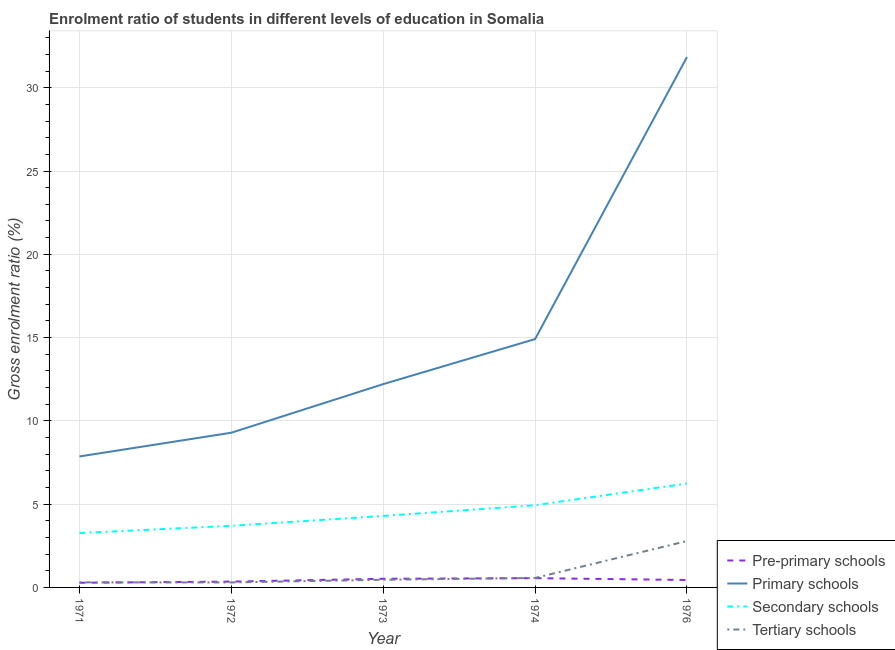How many different coloured lines are there?
Provide a short and direct response. 4. What is the gross enrolment ratio in pre-primary schools in 1974?
Ensure brevity in your answer.  0.56. Across all years, what is the maximum gross enrolment ratio in primary schools?
Offer a terse response. 31.84. Across all years, what is the minimum gross enrolment ratio in secondary schools?
Your answer should be very brief. 3.26. In which year was the gross enrolment ratio in pre-primary schools maximum?
Provide a succinct answer. 1974. What is the total gross enrolment ratio in pre-primary schools in the graph?
Provide a short and direct response. 2.15. What is the difference between the gross enrolment ratio in primary schools in 1974 and that in 1976?
Give a very brief answer. -16.93. What is the difference between the gross enrolment ratio in primary schools in 1973 and the gross enrolment ratio in secondary schools in 1976?
Keep it short and to the point. 5.97. What is the average gross enrolment ratio in secondary schools per year?
Your answer should be very brief. 4.49. In the year 1973, what is the difference between the gross enrolment ratio in primary schools and gross enrolment ratio in secondary schools?
Your answer should be compact. 7.91. What is the ratio of the gross enrolment ratio in pre-primary schools in 1971 to that in 1973?
Your answer should be very brief. 0.54. Is the gross enrolment ratio in pre-primary schools in 1971 less than that in 1976?
Your response must be concise. Yes. What is the difference between the highest and the second highest gross enrolment ratio in secondary schools?
Offer a very short reply. 1.3. What is the difference between the highest and the lowest gross enrolment ratio in primary schools?
Your answer should be compact. 23.98. Is the sum of the gross enrolment ratio in secondary schools in 1972 and 1973 greater than the maximum gross enrolment ratio in primary schools across all years?
Provide a succinct answer. No. Is it the case that in every year, the sum of the gross enrolment ratio in secondary schools and gross enrolment ratio in pre-primary schools is greater than the sum of gross enrolment ratio in tertiary schools and gross enrolment ratio in primary schools?
Your answer should be compact. Yes. Does the gross enrolment ratio in secondary schools monotonically increase over the years?
Make the answer very short. Yes. Is the gross enrolment ratio in tertiary schools strictly greater than the gross enrolment ratio in secondary schools over the years?
Keep it short and to the point. No. Is the gross enrolment ratio in pre-primary schools strictly less than the gross enrolment ratio in tertiary schools over the years?
Provide a short and direct response. No. How many years are there in the graph?
Give a very brief answer. 5. What is the difference between two consecutive major ticks on the Y-axis?
Make the answer very short. 5. Does the graph contain grids?
Provide a succinct answer. Yes. Where does the legend appear in the graph?
Offer a terse response. Bottom right. How are the legend labels stacked?
Ensure brevity in your answer.  Vertical. What is the title of the graph?
Your answer should be compact. Enrolment ratio of students in different levels of education in Somalia. What is the label or title of the Y-axis?
Provide a succinct answer. Gross enrolment ratio (%). What is the Gross enrolment ratio (%) in Pre-primary schools in 1971?
Give a very brief answer. 0.28. What is the Gross enrolment ratio (%) in Primary schools in 1971?
Your answer should be compact. 7.86. What is the Gross enrolment ratio (%) in Secondary schools in 1971?
Your response must be concise. 3.26. What is the Gross enrolment ratio (%) in Tertiary schools in 1971?
Your response must be concise. 0.3. What is the Gross enrolment ratio (%) in Pre-primary schools in 1972?
Offer a terse response. 0.35. What is the Gross enrolment ratio (%) in Primary schools in 1972?
Your response must be concise. 9.29. What is the Gross enrolment ratio (%) in Secondary schools in 1972?
Ensure brevity in your answer.  3.7. What is the Gross enrolment ratio (%) of Tertiary schools in 1972?
Your answer should be compact. 0.3. What is the Gross enrolment ratio (%) of Pre-primary schools in 1973?
Offer a very short reply. 0.52. What is the Gross enrolment ratio (%) of Primary schools in 1973?
Provide a short and direct response. 12.21. What is the Gross enrolment ratio (%) in Secondary schools in 1973?
Provide a succinct answer. 4.29. What is the Gross enrolment ratio (%) in Tertiary schools in 1973?
Give a very brief answer. 0.46. What is the Gross enrolment ratio (%) of Pre-primary schools in 1974?
Your answer should be very brief. 0.56. What is the Gross enrolment ratio (%) of Primary schools in 1974?
Offer a very short reply. 14.91. What is the Gross enrolment ratio (%) in Secondary schools in 1974?
Provide a succinct answer. 4.94. What is the Gross enrolment ratio (%) of Tertiary schools in 1974?
Your answer should be very brief. 0.57. What is the Gross enrolment ratio (%) of Pre-primary schools in 1976?
Provide a short and direct response. 0.45. What is the Gross enrolment ratio (%) of Primary schools in 1976?
Ensure brevity in your answer.  31.84. What is the Gross enrolment ratio (%) of Secondary schools in 1976?
Your answer should be very brief. 6.24. What is the Gross enrolment ratio (%) in Tertiary schools in 1976?
Offer a very short reply. 2.78. Across all years, what is the maximum Gross enrolment ratio (%) in Pre-primary schools?
Provide a succinct answer. 0.56. Across all years, what is the maximum Gross enrolment ratio (%) in Primary schools?
Your response must be concise. 31.84. Across all years, what is the maximum Gross enrolment ratio (%) in Secondary schools?
Offer a terse response. 6.24. Across all years, what is the maximum Gross enrolment ratio (%) of Tertiary schools?
Your response must be concise. 2.78. Across all years, what is the minimum Gross enrolment ratio (%) in Pre-primary schools?
Ensure brevity in your answer.  0.28. Across all years, what is the minimum Gross enrolment ratio (%) of Primary schools?
Your answer should be very brief. 7.86. Across all years, what is the minimum Gross enrolment ratio (%) of Secondary schools?
Make the answer very short. 3.26. Across all years, what is the minimum Gross enrolment ratio (%) of Tertiary schools?
Ensure brevity in your answer.  0.3. What is the total Gross enrolment ratio (%) in Pre-primary schools in the graph?
Your answer should be compact. 2.15. What is the total Gross enrolment ratio (%) of Primary schools in the graph?
Provide a succinct answer. 76.11. What is the total Gross enrolment ratio (%) of Secondary schools in the graph?
Keep it short and to the point. 22.43. What is the total Gross enrolment ratio (%) of Tertiary schools in the graph?
Offer a terse response. 4.42. What is the difference between the Gross enrolment ratio (%) in Pre-primary schools in 1971 and that in 1972?
Ensure brevity in your answer.  -0.07. What is the difference between the Gross enrolment ratio (%) of Primary schools in 1971 and that in 1972?
Make the answer very short. -1.43. What is the difference between the Gross enrolment ratio (%) of Secondary schools in 1971 and that in 1972?
Provide a succinct answer. -0.44. What is the difference between the Gross enrolment ratio (%) of Tertiary schools in 1971 and that in 1972?
Your response must be concise. 0. What is the difference between the Gross enrolment ratio (%) of Pre-primary schools in 1971 and that in 1973?
Provide a short and direct response. -0.24. What is the difference between the Gross enrolment ratio (%) of Primary schools in 1971 and that in 1973?
Provide a short and direct response. -4.34. What is the difference between the Gross enrolment ratio (%) in Secondary schools in 1971 and that in 1973?
Offer a very short reply. -1.03. What is the difference between the Gross enrolment ratio (%) in Tertiary schools in 1971 and that in 1973?
Provide a succinct answer. -0.16. What is the difference between the Gross enrolment ratio (%) of Pre-primary schools in 1971 and that in 1974?
Provide a short and direct response. -0.28. What is the difference between the Gross enrolment ratio (%) in Primary schools in 1971 and that in 1974?
Provide a short and direct response. -7.05. What is the difference between the Gross enrolment ratio (%) of Secondary schools in 1971 and that in 1974?
Provide a succinct answer. -1.67. What is the difference between the Gross enrolment ratio (%) in Tertiary schools in 1971 and that in 1974?
Provide a succinct answer. -0.26. What is the difference between the Gross enrolment ratio (%) of Pre-primary schools in 1971 and that in 1976?
Your answer should be compact. -0.17. What is the difference between the Gross enrolment ratio (%) in Primary schools in 1971 and that in 1976?
Keep it short and to the point. -23.98. What is the difference between the Gross enrolment ratio (%) of Secondary schools in 1971 and that in 1976?
Your response must be concise. -2.97. What is the difference between the Gross enrolment ratio (%) of Tertiary schools in 1971 and that in 1976?
Your answer should be compact. -2.48. What is the difference between the Gross enrolment ratio (%) of Pre-primary schools in 1972 and that in 1973?
Provide a succinct answer. -0.17. What is the difference between the Gross enrolment ratio (%) in Primary schools in 1972 and that in 1973?
Make the answer very short. -2.92. What is the difference between the Gross enrolment ratio (%) in Secondary schools in 1972 and that in 1973?
Provide a short and direct response. -0.59. What is the difference between the Gross enrolment ratio (%) in Tertiary schools in 1972 and that in 1973?
Provide a short and direct response. -0.16. What is the difference between the Gross enrolment ratio (%) in Pre-primary schools in 1972 and that in 1974?
Provide a short and direct response. -0.21. What is the difference between the Gross enrolment ratio (%) in Primary schools in 1972 and that in 1974?
Make the answer very short. -5.62. What is the difference between the Gross enrolment ratio (%) of Secondary schools in 1972 and that in 1974?
Give a very brief answer. -1.23. What is the difference between the Gross enrolment ratio (%) in Tertiary schools in 1972 and that in 1974?
Make the answer very short. -0.27. What is the difference between the Gross enrolment ratio (%) of Pre-primary schools in 1972 and that in 1976?
Provide a succinct answer. -0.1. What is the difference between the Gross enrolment ratio (%) of Primary schools in 1972 and that in 1976?
Offer a very short reply. -22.55. What is the difference between the Gross enrolment ratio (%) in Secondary schools in 1972 and that in 1976?
Offer a very short reply. -2.54. What is the difference between the Gross enrolment ratio (%) of Tertiary schools in 1972 and that in 1976?
Your answer should be compact. -2.48. What is the difference between the Gross enrolment ratio (%) in Pre-primary schools in 1973 and that in 1974?
Keep it short and to the point. -0.04. What is the difference between the Gross enrolment ratio (%) of Primary schools in 1973 and that in 1974?
Provide a short and direct response. -2.7. What is the difference between the Gross enrolment ratio (%) in Secondary schools in 1973 and that in 1974?
Your response must be concise. -0.64. What is the difference between the Gross enrolment ratio (%) of Tertiary schools in 1973 and that in 1974?
Keep it short and to the point. -0.11. What is the difference between the Gross enrolment ratio (%) of Pre-primary schools in 1973 and that in 1976?
Provide a short and direct response. 0.07. What is the difference between the Gross enrolment ratio (%) in Primary schools in 1973 and that in 1976?
Offer a terse response. -19.63. What is the difference between the Gross enrolment ratio (%) of Secondary schools in 1973 and that in 1976?
Provide a short and direct response. -1.95. What is the difference between the Gross enrolment ratio (%) of Tertiary schools in 1973 and that in 1976?
Offer a very short reply. -2.32. What is the difference between the Gross enrolment ratio (%) of Pre-primary schools in 1974 and that in 1976?
Offer a terse response. 0.11. What is the difference between the Gross enrolment ratio (%) in Primary schools in 1974 and that in 1976?
Ensure brevity in your answer.  -16.93. What is the difference between the Gross enrolment ratio (%) in Secondary schools in 1974 and that in 1976?
Offer a very short reply. -1.3. What is the difference between the Gross enrolment ratio (%) in Tertiary schools in 1974 and that in 1976?
Ensure brevity in your answer.  -2.22. What is the difference between the Gross enrolment ratio (%) of Pre-primary schools in 1971 and the Gross enrolment ratio (%) of Primary schools in 1972?
Provide a succinct answer. -9.01. What is the difference between the Gross enrolment ratio (%) in Pre-primary schools in 1971 and the Gross enrolment ratio (%) in Secondary schools in 1972?
Offer a very short reply. -3.42. What is the difference between the Gross enrolment ratio (%) of Pre-primary schools in 1971 and the Gross enrolment ratio (%) of Tertiary schools in 1972?
Your answer should be compact. -0.02. What is the difference between the Gross enrolment ratio (%) in Primary schools in 1971 and the Gross enrolment ratio (%) in Secondary schools in 1972?
Your answer should be compact. 4.16. What is the difference between the Gross enrolment ratio (%) in Primary schools in 1971 and the Gross enrolment ratio (%) in Tertiary schools in 1972?
Provide a short and direct response. 7.56. What is the difference between the Gross enrolment ratio (%) in Secondary schools in 1971 and the Gross enrolment ratio (%) in Tertiary schools in 1972?
Your answer should be compact. 2.97. What is the difference between the Gross enrolment ratio (%) of Pre-primary schools in 1971 and the Gross enrolment ratio (%) of Primary schools in 1973?
Your answer should be very brief. -11.93. What is the difference between the Gross enrolment ratio (%) of Pre-primary schools in 1971 and the Gross enrolment ratio (%) of Secondary schools in 1973?
Make the answer very short. -4.01. What is the difference between the Gross enrolment ratio (%) in Pre-primary schools in 1971 and the Gross enrolment ratio (%) in Tertiary schools in 1973?
Your response must be concise. -0.18. What is the difference between the Gross enrolment ratio (%) of Primary schools in 1971 and the Gross enrolment ratio (%) of Secondary schools in 1973?
Keep it short and to the point. 3.57. What is the difference between the Gross enrolment ratio (%) in Primary schools in 1971 and the Gross enrolment ratio (%) in Tertiary schools in 1973?
Keep it short and to the point. 7.4. What is the difference between the Gross enrolment ratio (%) of Secondary schools in 1971 and the Gross enrolment ratio (%) of Tertiary schools in 1973?
Provide a succinct answer. 2.8. What is the difference between the Gross enrolment ratio (%) in Pre-primary schools in 1971 and the Gross enrolment ratio (%) in Primary schools in 1974?
Provide a short and direct response. -14.63. What is the difference between the Gross enrolment ratio (%) of Pre-primary schools in 1971 and the Gross enrolment ratio (%) of Secondary schools in 1974?
Your response must be concise. -4.66. What is the difference between the Gross enrolment ratio (%) in Pre-primary schools in 1971 and the Gross enrolment ratio (%) in Tertiary schools in 1974?
Your response must be concise. -0.29. What is the difference between the Gross enrolment ratio (%) in Primary schools in 1971 and the Gross enrolment ratio (%) in Secondary schools in 1974?
Your answer should be very brief. 2.93. What is the difference between the Gross enrolment ratio (%) of Primary schools in 1971 and the Gross enrolment ratio (%) of Tertiary schools in 1974?
Your answer should be very brief. 7.3. What is the difference between the Gross enrolment ratio (%) of Secondary schools in 1971 and the Gross enrolment ratio (%) of Tertiary schools in 1974?
Ensure brevity in your answer.  2.7. What is the difference between the Gross enrolment ratio (%) in Pre-primary schools in 1971 and the Gross enrolment ratio (%) in Primary schools in 1976?
Your response must be concise. -31.56. What is the difference between the Gross enrolment ratio (%) of Pre-primary schools in 1971 and the Gross enrolment ratio (%) of Secondary schools in 1976?
Make the answer very short. -5.96. What is the difference between the Gross enrolment ratio (%) in Pre-primary schools in 1971 and the Gross enrolment ratio (%) in Tertiary schools in 1976?
Give a very brief answer. -2.5. What is the difference between the Gross enrolment ratio (%) in Primary schools in 1971 and the Gross enrolment ratio (%) in Secondary schools in 1976?
Offer a very short reply. 1.63. What is the difference between the Gross enrolment ratio (%) of Primary schools in 1971 and the Gross enrolment ratio (%) of Tertiary schools in 1976?
Make the answer very short. 5.08. What is the difference between the Gross enrolment ratio (%) of Secondary schools in 1971 and the Gross enrolment ratio (%) of Tertiary schools in 1976?
Make the answer very short. 0.48. What is the difference between the Gross enrolment ratio (%) in Pre-primary schools in 1972 and the Gross enrolment ratio (%) in Primary schools in 1973?
Keep it short and to the point. -11.86. What is the difference between the Gross enrolment ratio (%) of Pre-primary schools in 1972 and the Gross enrolment ratio (%) of Secondary schools in 1973?
Provide a short and direct response. -3.94. What is the difference between the Gross enrolment ratio (%) in Pre-primary schools in 1972 and the Gross enrolment ratio (%) in Tertiary schools in 1973?
Offer a very short reply. -0.11. What is the difference between the Gross enrolment ratio (%) of Primary schools in 1972 and the Gross enrolment ratio (%) of Secondary schools in 1973?
Provide a succinct answer. 5. What is the difference between the Gross enrolment ratio (%) in Primary schools in 1972 and the Gross enrolment ratio (%) in Tertiary schools in 1973?
Give a very brief answer. 8.83. What is the difference between the Gross enrolment ratio (%) of Secondary schools in 1972 and the Gross enrolment ratio (%) of Tertiary schools in 1973?
Offer a very short reply. 3.24. What is the difference between the Gross enrolment ratio (%) in Pre-primary schools in 1972 and the Gross enrolment ratio (%) in Primary schools in 1974?
Provide a succinct answer. -14.56. What is the difference between the Gross enrolment ratio (%) of Pre-primary schools in 1972 and the Gross enrolment ratio (%) of Secondary schools in 1974?
Keep it short and to the point. -4.58. What is the difference between the Gross enrolment ratio (%) in Pre-primary schools in 1972 and the Gross enrolment ratio (%) in Tertiary schools in 1974?
Your answer should be very brief. -0.22. What is the difference between the Gross enrolment ratio (%) in Primary schools in 1972 and the Gross enrolment ratio (%) in Secondary schools in 1974?
Ensure brevity in your answer.  4.35. What is the difference between the Gross enrolment ratio (%) in Primary schools in 1972 and the Gross enrolment ratio (%) in Tertiary schools in 1974?
Keep it short and to the point. 8.72. What is the difference between the Gross enrolment ratio (%) in Secondary schools in 1972 and the Gross enrolment ratio (%) in Tertiary schools in 1974?
Give a very brief answer. 3.13. What is the difference between the Gross enrolment ratio (%) in Pre-primary schools in 1972 and the Gross enrolment ratio (%) in Primary schools in 1976?
Offer a terse response. -31.49. What is the difference between the Gross enrolment ratio (%) in Pre-primary schools in 1972 and the Gross enrolment ratio (%) in Secondary schools in 1976?
Provide a succinct answer. -5.89. What is the difference between the Gross enrolment ratio (%) of Pre-primary schools in 1972 and the Gross enrolment ratio (%) of Tertiary schools in 1976?
Give a very brief answer. -2.43. What is the difference between the Gross enrolment ratio (%) in Primary schools in 1972 and the Gross enrolment ratio (%) in Secondary schools in 1976?
Keep it short and to the point. 3.05. What is the difference between the Gross enrolment ratio (%) in Primary schools in 1972 and the Gross enrolment ratio (%) in Tertiary schools in 1976?
Provide a short and direct response. 6.5. What is the difference between the Gross enrolment ratio (%) in Secondary schools in 1972 and the Gross enrolment ratio (%) in Tertiary schools in 1976?
Your answer should be compact. 0.92. What is the difference between the Gross enrolment ratio (%) in Pre-primary schools in 1973 and the Gross enrolment ratio (%) in Primary schools in 1974?
Provide a succinct answer. -14.39. What is the difference between the Gross enrolment ratio (%) of Pre-primary schools in 1973 and the Gross enrolment ratio (%) of Secondary schools in 1974?
Your answer should be compact. -4.42. What is the difference between the Gross enrolment ratio (%) of Pre-primary schools in 1973 and the Gross enrolment ratio (%) of Tertiary schools in 1974?
Offer a terse response. -0.05. What is the difference between the Gross enrolment ratio (%) in Primary schools in 1973 and the Gross enrolment ratio (%) in Secondary schools in 1974?
Provide a short and direct response. 7.27. What is the difference between the Gross enrolment ratio (%) of Primary schools in 1973 and the Gross enrolment ratio (%) of Tertiary schools in 1974?
Your answer should be compact. 11.64. What is the difference between the Gross enrolment ratio (%) of Secondary schools in 1973 and the Gross enrolment ratio (%) of Tertiary schools in 1974?
Ensure brevity in your answer.  3.72. What is the difference between the Gross enrolment ratio (%) in Pre-primary schools in 1973 and the Gross enrolment ratio (%) in Primary schools in 1976?
Your answer should be very brief. -31.32. What is the difference between the Gross enrolment ratio (%) of Pre-primary schools in 1973 and the Gross enrolment ratio (%) of Secondary schools in 1976?
Ensure brevity in your answer.  -5.72. What is the difference between the Gross enrolment ratio (%) of Pre-primary schools in 1973 and the Gross enrolment ratio (%) of Tertiary schools in 1976?
Give a very brief answer. -2.26. What is the difference between the Gross enrolment ratio (%) in Primary schools in 1973 and the Gross enrolment ratio (%) in Secondary schools in 1976?
Keep it short and to the point. 5.97. What is the difference between the Gross enrolment ratio (%) in Primary schools in 1973 and the Gross enrolment ratio (%) in Tertiary schools in 1976?
Your response must be concise. 9.42. What is the difference between the Gross enrolment ratio (%) of Secondary schools in 1973 and the Gross enrolment ratio (%) of Tertiary schools in 1976?
Offer a very short reply. 1.51. What is the difference between the Gross enrolment ratio (%) of Pre-primary schools in 1974 and the Gross enrolment ratio (%) of Primary schools in 1976?
Ensure brevity in your answer.  -31.28. What is the difference between the Gross enrolment ratio (%) of Pre-primary schools in 1974 and the Gross enrolment ratio (%) of Secondary schools in 1976?
Your answer should be compact. -5.68. What is the difference between the Gross enrolment ratio (%) in Pre-primary schools in 1974 and the Gross enrolment ratio (%) in Tertiary schools in 1976?
Make the answer very short. -2.23. What is the difference between the Gross enrolment ratio (%) in Primary schools in 1974 and the Gross enrolment ratio (%) in Secondary schools in 1976?
Provide a succinct answer. 8.67. What is the difference between the Gross enrolment ratio (%) of Primary schools in 1974 and the Gross enrolment ratio (%) of Tertiary schools in 1976?
Provide a succinct answer. 12.13. What is the difference between the Gross enrolment ratio (%) in Secondary schools in 1974 and the Gross enrolment ratio (%) in Tertiary schools in 1976?
Give a very brief answer. 2.15. What is the average Gross enrolment ratio (%) of Pre-primary schools per year?
Give a very brief answer. 0.43. What is the average Gross enrolment ratio (%) in Primary schools per year?
Provide a succinct answer. 15.22. What is the average Gross enrolment ratio (%) of Secondary schools per year?
Make the answer very short. 4.49. What is the average Gross enrolment ratio (%) of Tertiary schools per year?
Your answer should be very brief. 0.88. In the year 1971, what is the difference between the Gross enrolment ratio (%) in Pre-primary schools and Gross enrolment ratio (%) in Primary schools?
Offer a terse response. -7.58. In the year 1971, what is the difference between the Gross enrolment ratio (%) of Pre-primary schools and Gross enrolment ratio (%) of Secondary schools?
Offer a very short reply. -2.98. In the year 1971, what is the difference between the Gross enrolment ratio (%) of Pre-primary schools and Gross enrolment ratio (%) of Tertiary schools?
Your answer should be compact. -0.02. In the year 1971, what is the difference between the Gross enrolment ratio (%) of Primary schools and Gross enrolment ratio (%) of Secondary schools?
Your answer should be compact. 4.6. In the year 1971, what is the difference between the Gross enrolment ratio (%) of Primary schools and Gross enrolment ratio (%) of Tertiary schools?
Your answer should be very brief. 7.56. In the year 1971, what is the difference between the Gross enrolment ratio (%) of Secondary schools and Gross enrolment ratio (%) of Tertiary schools?
Keep it short and to the point. 2.96. In the year 1972, what is the difference between the Gross enrolment ratio (%) in Pre-primary schools and Gross enrolment ratio (%) in Primary schools?
Offer a very short reply. -8.94. In the year 1972, what is the difference between the Gross enrolment ratio (%) of Pre-primary schools and Gross enrolment ratio (%) of Secondary schools?
Provide a short and direct response. -3.35. In the year 1972, what is the difference between the Gross enrolment ratio (%) of Pre-primary schools and Gross enrolment ratio (%) of Tertiary schools?
Your response must be concise. 0.05. In the year 1972, what is the difference between the Gross enrolment ratio (%) in Primary schools and Gross enrolment ratio (%) in Secondary schools?
Provide a short and direct response. 5.59. In the year 1972, what is the difference between the Gross enrolment ratio (%) in Primary schools and Gross enrolment ratio (%) in Tertiary schools?
Offer a very short reply. 8.99. In the year 1972, what is the difference between the Gross enrolment ratio (%) in Secondary schools and Gross enrolment ratio (%) in Tertiary schools?
Provide a succinct answer. 3.4. In the year 1973, what is the difference between the Gross enrolment ratio (%) of Pre-primary schools and Gross enrolment ratio (%) of Primary schools?
Offer a very short reply. -11.69. In the year 1973, what is the difference between the Gross enrolment ratio (%) of Pre-primary schools and Gross enrolment ratio (%) of Secondary schools?
Provide a succinct answer. -3.77. In the year 1973, what is the difference between the Gross enrolment ratio (%) in Pre-primary schools and Gross enrolment ratio (%) in Tertiary schools?
Keep it short and to the point. 0.06. In the year 1973, what is the difference between the Gross enrolment ratio (%) in Primary schools and Gross enrolment ratio (%) in Secondary schools?
Give a very brief answer. 7.91. In the year 1973, what is the difference between the Gross enrolment ratio (%) of Primary schools and Gross enrolment ratio (%) of Tertiary schools?
Keep it short and to the point. 11.75. In the year 1973, what is the difference between the Gross enrolment ratio (%) of Secondary schools and Gross enrolment ratio (%) of Tertiary schools?
Your answer should be very brief. 3.83. In the year 1974, what is the difference between the Gross enrolment ratio (%) in Pre-primary schools and Gross enrolment ratio (%) in Primary schools?
Give a very brief answer. -14.35. In the year 1974, what is the difference between the Gross enrolment ratio (%) of Pre-primary schools and Gross enrolment ratio (%) of Secondary schools?
Provide a succinct answer. -4.38. In the year 1974, what is the difference between the Gross enrolment ratio (%) in Pre-primary schools and Gross enrolment ratio (%) in Tertiary schools?
Provide a short and direct response. -0.01. In the year 1974, what is the difference between the Gross enrolment ratio (%) in Primary schools and Gross enrolment ratio (%) in Secondary schools?
Your answer should be compact. 9.97. In the year 1974, what is the difference between the Gross enrolment ratio (%) in Primary schools and Gross enrolment ratio (%) in Tertiary schools?
Provide a short and direct response. 14.34. In the year 1974, what is the difference between the Gross enrolment ratio (%) of Secondary schools and Gross enrolment ratio (%) of Tertiary schools?
Give a very brief answer. 4.37. In the year 1976, what is the difference between the Gross enrolment ratio (%) in Pre-primary schools and Gross enrolment ratio (%) in Primary schools?
Keep it short and to the point. -31.39. In the year 1976, what is the difference between the Gross enrolment ratio (%) of Pre-primary schools and Gross enrolment ratio (%) of Secondary schools?
Offer a terse response. -5.79. In the year 1976, what is the difference between the Gross enrolment ratio (%) of Pre-primary schools and Gross enrolment ratio (%) of Tertiary schools?
Provide a succinct answer. -2.34. In the year 1976, what is the difference between the Gross enrolment ratio (%) of Primary schools and Gross enrolment ratio (%) of Secondary schools?
Keep it short and to the point. 25.6. In the year 1976, what is the difference between the Gross enrolment ratio (%) in Primary schools and Gross enrolment ratio (%) in Tertiary schools?
Ensure brevity in your answer.  29.06. In the year 1976, what is the difference between the Gross enrolment ratio (%) of Secondary schools and Gross enrolment ratio (%) of Tertiary schools?
Give a very brief answer. 3.45. What is the ratio of the Gross enrolment ratio (%) in Pre-primary schools in 1971 to that in 1972?
Offer a very short reply. 0.8. What is the ratio of the Gross enrolment ratio (%) of Primary schools in 1971 to that in 1972?
Keep it short and to the point. 0.85. What is the ratio of the Gross enrolment ratio (%) in Secondary schools in 1971 to that in 1972?
Your response must be concise. 0.88. What is the ratio of the Gross enrolment ratio (%) of Tertiary schools in 1971 to that in 1972?
Offer a terse response. 1.02. What is the ratio of the Gross enrolment ratio (%) in Pre-primary schools in 1971 to that in 1973?
Give a very brief answer. 0.54. What is the ratio of the Gross enrolment ratio (%) of Primary schools in 1971 to that in 1973?
Your answer should be compact. 0.64. What is the ratio of the Gross enrolment ratio (%) in Secondary schools in 1971 to that in 1973?
Make the answer very short. 0.76. What is the ratio of the Gross enrolment ratio (%) in Tertiary schools in 1971 to that in 1973?
Your response must be concise. 0.66. What is the ratio of the Gross enrolment ratio (%) in Pre-primary schools in 1971 to that in 1974?
Give a very brief answer. 0.5. What is the ratio of the Gross enrolment ratio (%) of Primary schools in 1971 to that in 1974?
Your answer should be compact. 0.53. What is the ratio of the Gross enrolment ratio (%) of Secondary schools in 1971 to that in 1974?
Give a very brief answer. 0.66. What is the ratio of the Gross enrolment ratio (%) in Tertiary schools in 1971 to that in 1974?
Keep it short and to the point. 0.54. What is the ratio of the Gross enrolment ratio (%) of Pre-primary schools in 1971 to that in 1976?
Provide a succinct answer. 0.63. What is the ratio of the Gross enrolment ratio (%) of Primary schools in 1971 to that in 1976?
Offer a very short reply. 0.25. What is the ratio of the Gross enrolment ratio (%) of Secondary schools in 1971 to that in 1976?
Your response must be concise. 0.52. What is the ratio of the Gross enrolment ratio (%) in Tertiary schools in 1971 to that in 1976?
Give a very brief answer. 0.11. What is the ratio of the Gross enrolment ratio (%) of Pre-primary schools in 1972 to that in 1973?
Your answer should be very brief. 0.67. What is the ratio of the Gross enrolment ratio (%) in Primary schools in 1972 to that in 1973?
Your response must be concise. 0.76. What is the ratio of the Gross enrolment ratio (%) in Secondary schools in 1972 to that in 1973?
Ensure brevity in your answer.  0.86. What is the ratio of the Gross enrolment ratio (%) of Tertiary schools in 1972 to that in 1973?
Keep it short and to the point. 0.65. What is the ratio of the Gross enrolment ratio (%) of Pre-primary schools in 1972 to that in 1974?
Your answer should be compact. 0.63. What is the ratio of the Gross enrolment ratio (%) in Primary schools in 1972 to that in 1974?
Offer a very short reply. 0.62. What is the ratio of the Gross enrolment ratio (%) in Tertiary schools in 1972 to that in 1974?
Your response must be concise. 0.53. What is the ratio of the Gross enrolment ratio (%) of Pre-primary schools in 1972 to that in 1976?
Your answer should be very brief. 0.78. What is the ratio of the Gross enrolment ratio (%) in Primary schools in 1972 to that in 1976?
Offer a terse response. 0.29. What is the ratio of the Gross enrolment ratio (%) in Secondary schools in 1972 to that in 1976?
Offer a terse response. 0.59. What is the ratio of the Gross enrolment ratio (%) of Tertiary schools in 1972 to that in 1976?
Ensure brevity in your answer.  0.11. What is the ratio of the Gross enrolment ratio (%) in Pre-primary schools in 1973 to that in 1974?
Ensure brevity in your answer.  0.93. What is the ratio of the Gross enrolment ratio (%) of Primary schools in 1973 to that in 1974?
Your response must be concise. 0.82. What is the ratio of the Gross enrolment ratio (%) of Secondary schools in 1973 to that in 1974?
Offer a terse response. 0.87. What is the ratio of the Gross enrolment ratio (%) of Tertiary schools in 1973 to that in 1974?
Provide a succinct answer. 0.81. What is the ratio of the Gross enrolment ratio (%) of Pre-primary schools in 1973 to that in 1976?
Offer a terse response. 1.16. What is the ratio of the Gross enrolment ratio (%) in Primary schools in 1973 to that in 1976?
Your answer should be compact. 0.38. What is the ratio of the Gross enrolment ratio (%) of Secondary schools in 1973 to that in 1976?
Make the answer very short. 0.69. What is the ratio of the Gross enrolment ratio (%) in Tertiary schools in 1973 to that in 1976?
Give a very brief answer. 0.17. What is the ratio of the Gross enrolment ratio (%) of Pre-primary schools in 1974 to that in 1976?
Keep it short and to the point. 1.25. What is the ratio of the Gross enrolment ratio (%) of Primary schools in 1974 to that in 1976?
Offer a very short reply. 0.47. What is the ratio of the Gross enrolment ratio (%) of Secondary schools in 1974 to that in 1976?
Provide a short and direct response. 0.79. What is the ratio of the Gross enrolment ratio (%) in Tertiary schools in 1974 to that in 1976?
Your answer should be very brief. 0.2. What is the difference between the highest and the second highest Gross enrolment ratio (%) of Pre-primary schools?
Give a very brief answer. 0.04. What is the difference between the highest and the second highest Gross enrolment ratio (%) in Primary schools?
Your answer should be compact. 16.93. What is the difference between the highest and the second highest Gross enrolment ratio (%) in Secondary schools?
Give a very brief answer. 1.3. What is the difference between the highest and the second highest Gross enrolment ratio (%) of Tertiary schools?
Make the answer very short. 2.22. What is the difference between the highest and the lowest Gross enrolment ratio (%) in Pre-primary schools?
Offer a terse response. 0.28. What is the difference between the highest and the lowest Gross enrolment ratio (%) of Primary schools?
Offer a very short reply. 23.98. What is the difference between the highest and the lowest Gross enrolment ratio (%) of Secondary schools?
Keep it short and to the point. 2.97. What is the difference between the highest and the lowest Gross enrolment ratio (%) in Tertiary schools?
Provide a succinct answer. 2.48. 